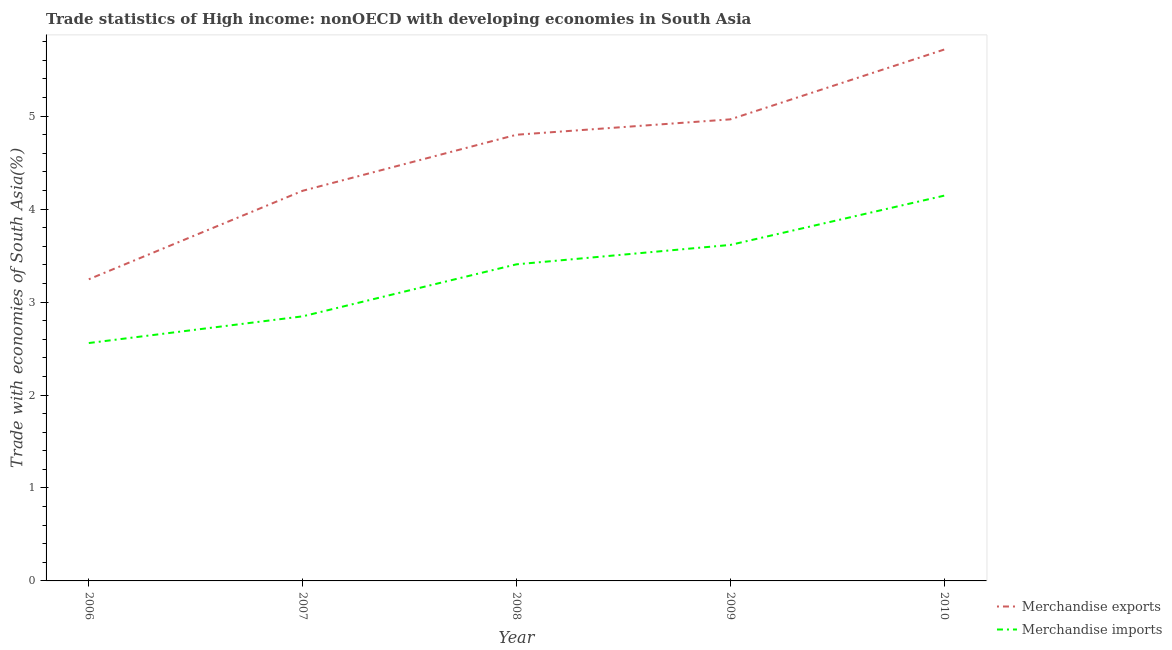Does the line corresponding to merchandise exports intersect with the line corresponding to merchandise imports?
Your answer should be compact. No. What is the merchandise imports in 2008?
Ensure brevity in your answer.  3.41. Across all years, what is the maximum merchandise exports?
Your answer should be very brief. 5.72. Across all years, what is the minimum merchandise imports?
Provide a short and direct response. 2.56. In which year was the merchandise imports minimum?
Provide a short and direct response. 2006. What is the total merchandise exports in the graph?
Give a very brief answer. 22.93. What is the difference between the merchandise imports in 2007 and that in 2009?
Provide a succinct answer. -0.77. What is the difference between the merchandise imports in 2007 and the merchandise exports in 2008?
Provide a succinct answer. -1.95. What is the average merchandise exports per year?
Provide a short and direct response. 4.59. In the year 2007, what is the difference between the merchandise exports and merchandise imports?
Keep it short and to the point. 1.35. What is the ratio of the merchandise imports in 2006 to that in 2007?
Make the answer very short. 0.9. Is the merchandise exports in 2009 less than that in 2010?
Make the answer very short. Yes. What is the difference between the highest and the second highest merchandise exports?
Offer a very short reply. 0.75. What is the difference between the highest and the lowest merchandise imports?
Ensure brevity in your answer.  1.59. Is the sum of the merchandise imports in 2006 and 2009 greater than the maximum merchandise exports across all years?
Offer a terse response. Yes. Does the merchandise imports monotonically increase over the years?
Your answer should be very brief. Yes. Is the merchandise imports strictly greater than the merchandise exports over the years?
Give a very brief answer. No. How many lines are there?
Give a very brief answer. 2. How many years are there in the graph?
Your response must be concise. 5. What is the difference between two consecutive major ticks on the Y-axis?
Offer a terse response. 1. Does the graph contain any zero values?
Offer a very short reply. No. How many legend labels are there?
Your response must be concise. 2. How are the legend labels stacked?
Offer a very short reply. Vertical. What is the title of the graph?
Offer a very short reply. Trade statistics of High income: nonOECD with developing economies in South Asia. Does "Nitrous oxide" appear as one of the legend labels in the graph?
Your response must be concise. No. What is the label or title of the X-axis?
Provide a succinct answer. Year. What is the label or title of the Y-axis?
Offer a very short reply. Trade with economies of South Asia(%). What is the Trade with economies of South Asia(%) in Merchandise exports in 2006?
Offer a terse response. 3.25. What is the Trade with economies of South Asia(%) of Merchandise imports in 2006?
Ensure brevity in your answer.  2.56. What is the Trade with economies of South Asia(%) in Merchandise exports in 2007?
Your answer should be compact. 4.2. What is the Trade with economies of South Asia(%) in Merchandise imports in 2007?
Give a very brief answer. 2.85. What is the Trade with economies of South Asia(%) of Merchandise exports in 2008?
Your response must be concise. 4.8. What is the Trade with economies of South Asia(%) of Merchandise imports in 2008?
Offer a very short reply. 3.41. What is the Trade with economies of South Asia(%) of Merchandise exports in 2009?
Your answer should be compact. 4.97. What is the Trade with economies of South Asia(%) in Merchandise imports in 2009?
Make the answer very short. 3.61. What is the Trade with economies of South Asia(%) of Merchandise exports in 2010?
Provide a succinct answer. 5.72. What is the Trade with economies of South Asia(%) in Merchandise imports in 2010?
Your response must be concise. 4.14. Across all years, what is the maximum Trade with economies of South Asia(%) in Merchandise exports?
Offer a very short reply. 5.72. Across all years, what is the maximum Trade with economies of South Asia(%) in Merchandise imports?
Provide a short and direct response. 4.14. Across all years, what is the minimum Trade with economies of South Asia(%) in Merchandise exports?
Offer a terse response. 3.25. Across all years, what is the minimum Trade with economies of South Asia(%) of Merchandise imports?
Keep it short and to the point. 2.56. What is the total Trade with economies of South Asia(%) of Merchandise exports in the graph?
Your response must be concise. 22.93. What is the total Trade with economies of South Asia(%) in Merchandise imports in the graph?
Offer a very short reply. 16.57. What is the difference between the Trade with economies of South Asia(%) of Merchandise exports in 2006 and that in 2007?
Offer a terse response. -0.95. What is the difference between the Trade with economies of South Asia(%) of Merchandise imports in 2006 and that in 2007?
Keep it short and to the point. -0.29. What is the difference between the Trade with economies of South Asia(%) in Merchandise exports in 2006 and that in 2008?
Make the answer very short. -1.55. What is the difference between the Trade with economies of South Asia(%) of Merchandise imports in 2006 and that in 2008?
Your answer should be compact. -0.85. What is the difference between the Trade with economies of South Asia(%) in Merchandise exports in 2006 and that in 2009?
Your response must be concise. -1.72. What is the difference between the Trade with economies of South Asia(%) in Merchandise imports in 2006 and that in 2009?
Offer a very short reply. -1.06. What is the difference between the Trade with economies of South Asia(%) in Merchandise exports in 2006 and that in 2010?
Offer a terse response. -2.47. What is the difference between the Trade with economies of South Asia(%) of Merchandise imports in 2006 and that in 2010?
Give a very brief answer. -1.59. What is the difference between the Trade with economies of South Asia(%) of Merchandise exports in 2007 and that in 2008?
Your answer should be compact. -0.6. What is the difference between the Trade with economies of South Asia(%) in Merchandise imports in 2007 and that in 2008?
Give a very brief answer. -0.56. What is the difference between the Trade with economies of South Asia(%) in Merchandise exports in 2007 and that in 2009?
Offer a very short reply. -0.77. What is the difference between the Trade with economies of South Asia(%) of Merchandise imports in 2007 and that in 2009?
Offer a terse response. -0.77. What is the difference between the Trade with economies of South Asia(%) in Merchandise exports in 2007 and that in 2010?
Ensure brevity in your answer.  -1.52. What is the difference between the Trade with economies of South Asia(%) of Merchandise imports in 2007 and that in 2010?
Your answer should be very brief. -1.3. What is the difference between the Trade with economies of South Asia(%) in Merchandise exports in 2008 and that in 2009?
Make the answer very short. -0.17. What is the difference between the Trade with economies of South Asia(%) in Merchandise imports in 2008 and that in 2009?
Provide a succinct answer. -0.21. What is the difference between the Trade with economies of South Asia(%) of Merchandise exports in 2008 and that in 2010?
Provide a succinct answer. -0.92. What is the difference between the Trade with economies of South Asia(%) in Merchandise imports in 2008 and that in 2010?
Ensure brevity in your answer.  -0.74. What is the difference between the Trade with economies of South Asia(%) of Merchandise exports in 2009 and that in 2010?
Your response must be concise. -0.75. What is the difference between the Trade with economies of South Asia(%) of Merchandise imports in 2009 and that in 2010?
Provide a short and direct response. -0.53. What is the difference between the Trade with economies of South Asia(%) of Merchandise exports in 2006 and the Trade with economies of South Asia(%) of Merchandise imports in 2007?
Provide a succinct answer. 0.4. What is the difference between the Trade with economies of South Asia(%) in Merchandise exports in 2006 and the Trade with economies of South Asia(%) in Merchandise imports in 2008?
Ensure brevity in your answer.  -0.16. What is the difference between the Trade with economies of South Asia(%) of Merchandise exports in 2006 and the Trade with economies of South Asia(%) of Merchandise imports in 2009?
Give a very brief answer. -0.37. What is the difference between the Trade with economies of South Asia(%) of Merchandise exports in 2006 and the Trade with economies of South Asia(%) of Merchandise imports in 2010?
Offer a very short reply. -0.9. What is the difference between the Trade with economies of South Asia(%) of Merchandise exports in 2007 and the Trade with economies of South Asia(%) of Merchandise imports in 2008?
Offer a very short reply. 0.79. What is the difference between the Trade with economies of South Asia(%) in Merchandise exports in 2007 and the Trade with economies of South Asia(%) in Merchandise imports in 2009?
Ensure brevity in your answer.  0.58. What is the difference between the Trade with economies of South Asia(%) in Merchandise exports in 2007 and the Trade with economies of South Asia(%) in Merchandise imports in 2010?
Provide a short and direct response. 0.05. What is the difference between the Trade with economies of South Asia(%) in Merchandise exports in 2008 and the Trade with economies of South Asia(%) in Merchandise imports in 2009?
Your answer should be very brief. 1.19. What is the difference between the Trade with economies of South Asia(%) of Merchandise exports in 2008 and the Trade with economies of South Asia(%) of Merchandise imports in 2010?
Keep it short and to the point. 0.66. What is the difference between the Trade with economies of South Asia(%) in Merchandise exports in 2009 and the Trade with economies of South Asia(%) in Merchandise imports in 2010?
Provide a succinct answer. 0.82. What is the average Trade with economies of South Asia(%) in Merchandise exports per year?
Keep it short and to the point. 4.58. What is the average Trade with economies of South Asia(%) of Merchandise imports per year?
Your answer should be very brief. 3.31. In the year 2006, what is the difference between the Trade with economies of South Asia(%) in Merchandise exports and Trade with economies of South Asia(%) in Merchandise imports?
Your answer should be very brief. 0.69. In the year 2007, what is the difference between the Trade with economies of South Asia(%) of Merchandise exports and Trade with economies of South Asia(%) of Merchandise imports?
Give a very brief answer. 1.35. In the year 2008, what is the difference between the Trade with economies of South Asia(%) of Merchandise exports and Trade with economies of South Asia(%) of Merchandise imports?
Offer a terse response. 1.39. In the year 2009, what is the difference between the Trade with economies of South Asia(%) of Merchandise exports and Trade with economies of South Asia(%) of Merchandise imports?
Offer a very short reply. 1.35. In the year 2010, what is the difference between the Trade with economies of South Asia(%) in Merchandise exports and Trade with economies of South Asia(%) in Merchandise imports?
Offer a very short reply. 1.57. What is the ratio of the Trade with economies of South Asia(%) of Merchandise exports in 2006 to that in 2007?
Provide a succinct answer. 0.77. What is the ratio of the Trade with economies of South Asia(%) of Merchandise imports in 2006 to that in 2007?
Provide a succinct answer. 0.9. What is the ratio of the Trade with economies of South Asia(%) in Merchandise exports in 2006 to that in 2008?
Provide a succinct answer. 0.68. What is the ratio of the Trade with economies of South Asia(%) in Merchandise imports in 2006 to that in 2008?
Keep it short and to the point. 0.75. What is the ratio of the Trade with economies of South Asia(%) in Merchandise exports in 2006 to that in 2009?
Your answer should be very brief. 0.65. What is the ratio of the Trade with economies of South Asia(%) in Merchandise imports in 2006 to that in 2009?
Provide a succinct answer. 0.71. What is the ratio of the Trade with economies of South Asia(%) of Merchandise exports in 2006 to that in 2010?
Your answer should be compact. 0.57. What is the ratio of the Trade with economies of South Asia(%) of Merchandise imports in 2006 to that in 2010?
Keep it short and to the point. 0.62. What is the ratio of the Trade with economies of South Asia(%) of Merchandise exports in 2007 to that in 2008?
Provide a short and direct response. 0.87. What is the ratio of the Trade with economies of South Asia(%) of Merchandise imports in 2007 to that in 2008?
Your response must be concise. 0.84. What is the ratio of the Trade with economies of South Asia(%) in Merchandise exports in 2007 to that in 2009?
Offer a very short reply. 0.85. What is the ratio of the Trade with economies of South Asia(%) of Merchandise imports in 2007 to that in 2009?
Provide a short and direct response. 0.79. What is the ratio of the Trade with economies of South Asia(%) of Merchandise exports in 2007 to that in 2010?
Provide a succinct answer. 0.73. What is the ratio of the Trade with economies of South Asia(%) in Merchandise imports in 2007 to that in 2010?
Provide a succinct answer. 0.69. What is the ratio of the Trade with economies of South Asia(%) in Merchandise exports in 2008 to that in 2009?
Offer a very short reply. 0.97. What is the ratio of the Trade with economies of South Asia(%) in Merchandise imports in 2008 to that in 2009?
Your answer should be very brief. 0.94. What is the ratio of the Trade with economies of South Asia(%) of Merchandise exports in 2008 to that in 2010?
Offer a very short reply. 0.84. What is the ratio of the Trade with economies of South Asia(%) of Merchandise imports in 2008 to that in 2010?
Provide a short and direct response. 0.82. What is the ratio of the Trade with economies of South Asia(%) in Merchandise exports in 2009 to that in 2010?
Offer a very short reply. 0.87. What is the ratio of the Trade with economies of South Asia(%) of Merchandise imports in 2009 to that in 2010?
Provide a short and direct response. 0.87. What is the difference between the highest and the second highest Trade with economies of South Asia(%) of Merchandise exports?
Give a very brief answer. 0.75. What is the difference between the highest and the second highest Trade with economies of South Asia(%) of Merchandise imports?
Provide a short and direct response. 0.53. What is the difference between the highest and the lowest Trade with economies of South Asia(%) of Merchandise exports?
Make the answer very short. 2.47. What is the difference between the highest and the lowest Trade with economies of South Asia(%) in Merchandise imports?
Your answer should be compact. 1.59. 